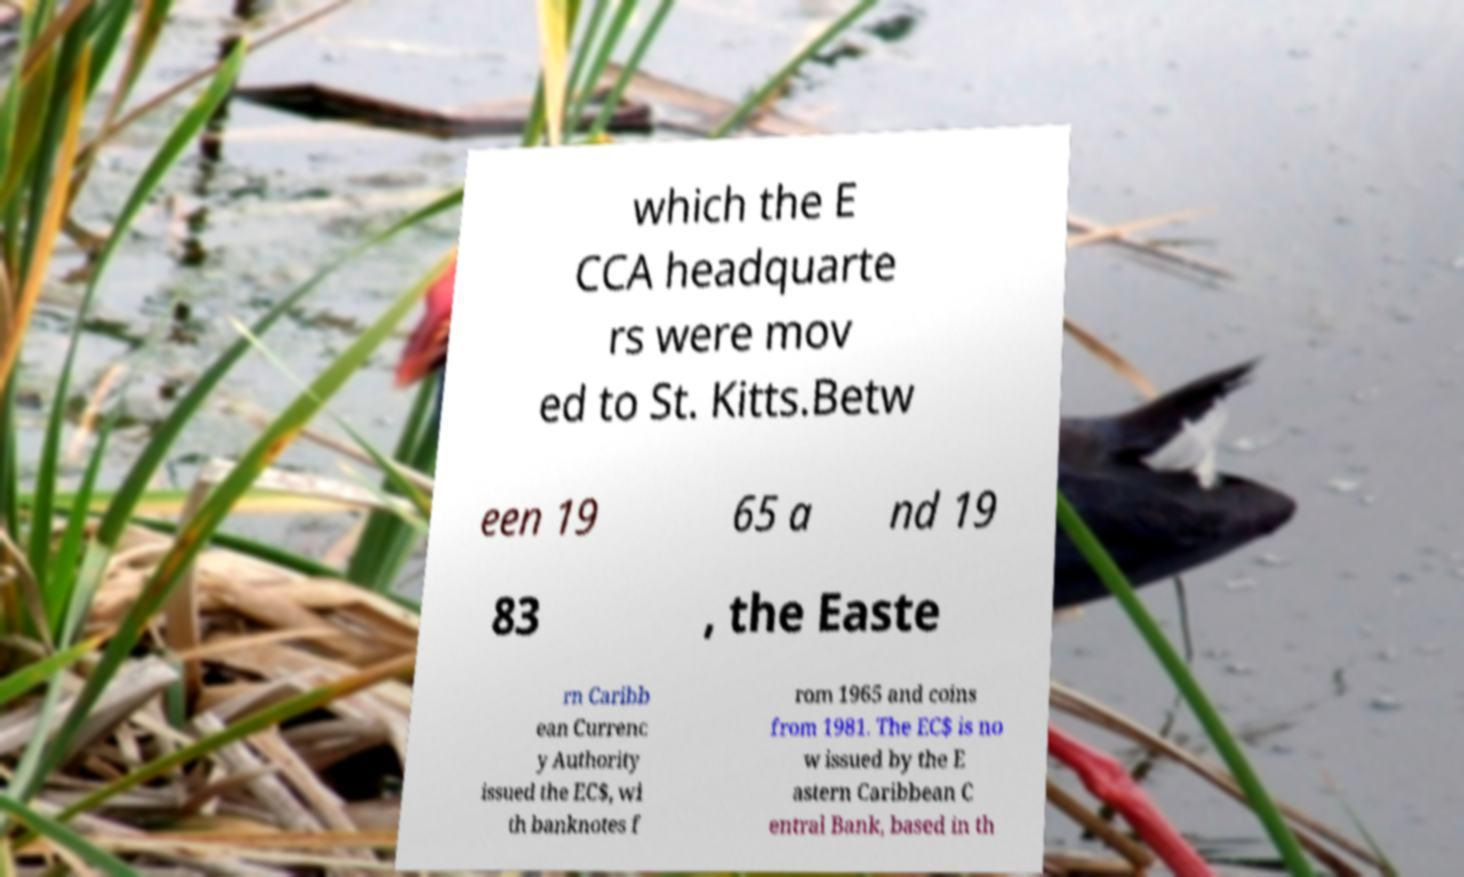Could you assist in decoding the text presented in this image and type it out clearly? which the E CCA headquarte rs were mov ed to St. Kitts.Betw een 19 65 a nd 19 83 , the Easte rn Caribb ean Currenc y Authority issued the EC$, wi th banknotes f rom 1965 and coins from 1981. The EC$ is no w issued by the E astern Caribbean C entral Bank, based in th 